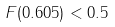Convert formula to latex. <formula><loc_0><loc_0><loc_500><loc_500>F ( 0 . 6 0 5 ) < 0 . 5</formula> 